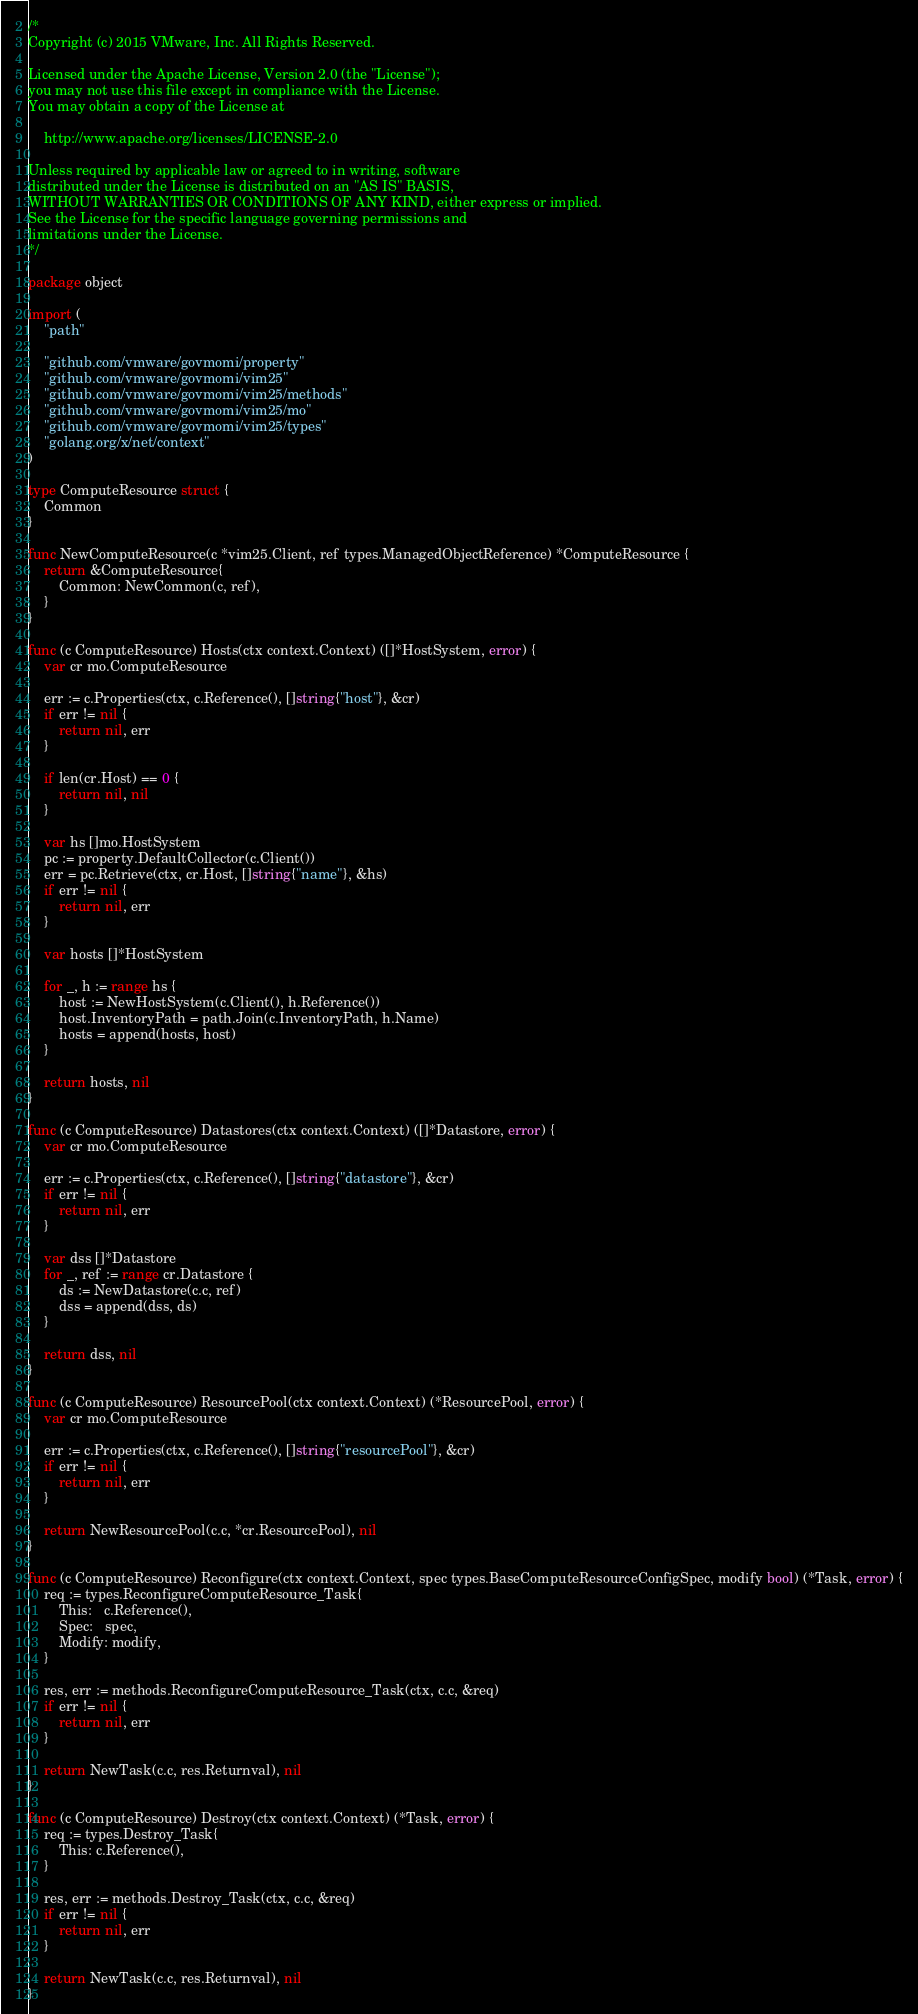<code> <loc_0><loc_0><loc_500><loc_500><_Go_>/*
Copyright (c) 2015 VMware, Inc. All Rights Reserved.

Licensed under the Apache License, Version 2.0 (the "License");
you may not use this file except in compliance with the License.
You may obtain a copy of the License at

    http://www.apache.org/licenses/LICENSE-2.0

Unless required by applicable law or agreed to in writing, software
distributed under the License is distributed on an "AS IS" BASIS,
WITHOUT WARRANTIES OR CONDITIONS OF ANY KIND, either express or implied.
See the License for the specific language governing permissions and
limitations under the License.
*/

package object

import (
	"path"

	"github.com/vmware/govmomi/property"
	"github.com/vmware/govmomi/vim25"
	"github.com/vmware/govmomi/vim25/methods"
	"github.com/vmware/govmomi/vim25/mo"
	"github.com/vmware/govmomi/vim25/types"
	"golang.org/x/net/context"
)

type ComputeResource struct {
	Common
}

func NewComputeResource(c *vim25.Client, ref types.ManagedObjectReference) *ComputeResource {
	return &ComputeResource{
		Common: NewCommon(c, ref),
	}
}

func (c ComputeResource) Hosts(ctx context.Context) ([]*HostSystem, error) {
	var cr mo.ComputeResource

	err := c.Properties(ctx, c.Reference(), []string{"host"}, &cr)
	if err != nil {
		return nil, err
	}

	if len(cr.Host) == 0 {
		return nil, nil
	}

	var hs []mo.HostSystem
	pc := property.DefaultCollector(c.Client())
	err = pc.Retrieve(ctx, cr.Host, []string{"name"}, &hs)
	if err != nil {
		return nil, err
	}

	var hosts []*HostSystem

	for _, h := range hs {
		host := NewHostSystem(c.Client(), h.Reference())
		host.InventoryPath = path.Join(c.InventoryPath, h.Name)
		hosts = append(hosts, host)
	}

	return hosts, nil
}

func (c ComputeResource) Datastores(ctx context.Context) ([]*Datastore, error) {
	var cr mo.ComputeResource

	err := c.Properties(ctx, c.Reference(), []string{"datastore"}, &cr)
	if err != nil {
		return nil, err
	}

	var dss []*Datastore
	for _, ref := range cr.Datastore {
		ds := NewDatastore(c.c, ref)
		dss = append(dss, ds)
	}

	return dss, nil
}

func (c ComputeResource) ResourcePool(ctx context.Context) (*ResourcePool, error) {
	var cr mo.ComputeResource

	err := c.Properties(ctx, c.Reference(), []string{"resourcePool"}, &cr)
	if err != nil {
		return nil, err
	}

	return NewResourcePool(c.c, *cr.ResourcePool), nil
}

func (c ComputeResource) Reconfigure(ctx context.Context, spec types.BaseComputeResourceConfigSpec, modify bool) (*Task, error) {
	req := types.ReconfigureComputeResource_Task{
		This:   c.Reference(),
		Spec:   spec,
		Modify: modify,
	}

	res, err := methods.ReconfigureComputeResource_Task(ctx, c.c, &req)
	if err != nil {
		return nil, err
	}

	return NewTask(c.c, res.Returnval), nil
}

func (c ComputeResource) Destroy(ctx context.Context) (*Task, error) {
	req := types.Destroy_Task{
		This: c.Reference(),
	}

	res, err := methods.Destroy_Task(ctx, c.c, &req)
	if err != nil {
		return nil, err
	}

	return NewTask(c.c, res.Returnval), nil
}
</code> 